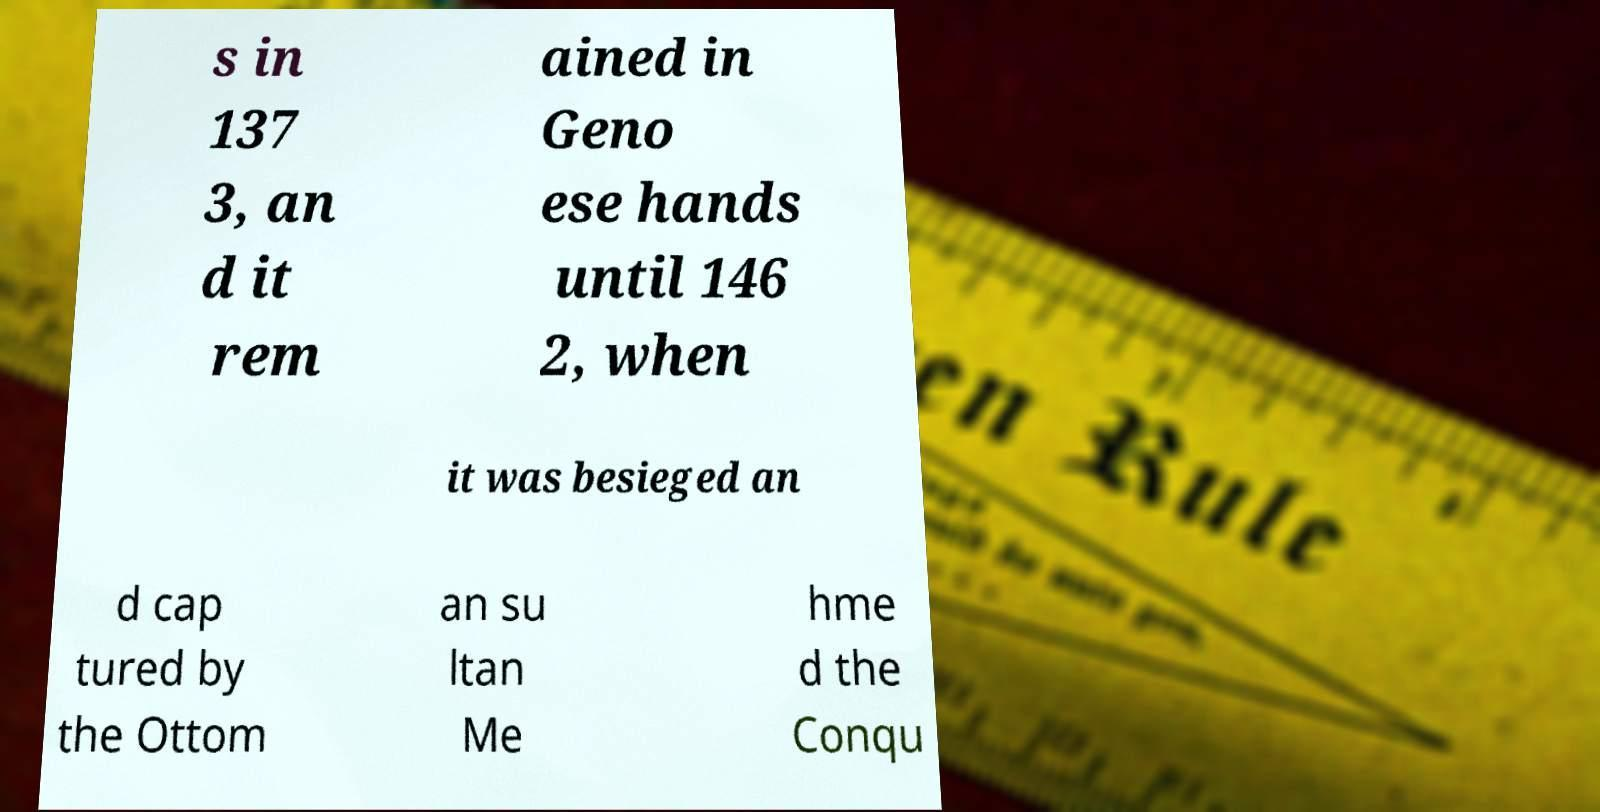For documentation purposes, I need the text within this image transcribed. Could you provide that? s in 137 3, an d it rem ained in Geno ese hands until 146 2, when it was besieged an d cap tured by the Ottom an su ltan Me hme d the Conqu 